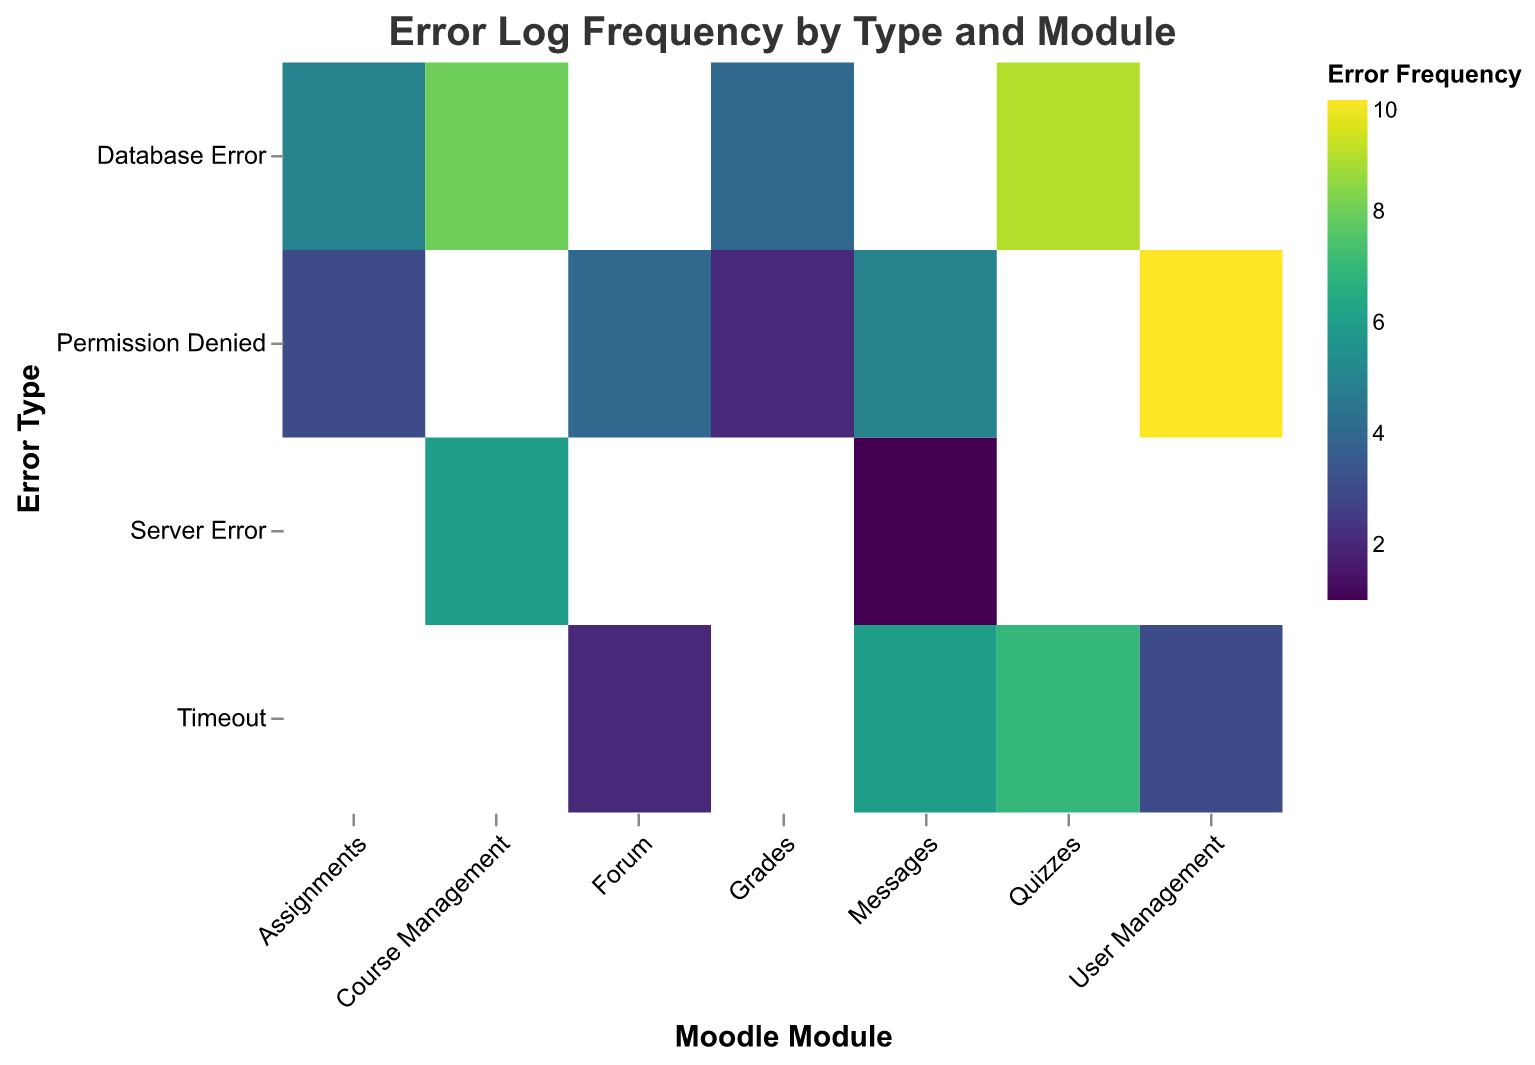What's the title of the figure? The title of the figure is usually located at the top of the chart and describes what the visualization is about. In this case, it is "Error Log Frequency by Type and Module".
Answer: Error Log Frequency by Type and Module How many different error types are there in the chart? The y-axis of the chart lists the distinct error types. By counting these labels, we can determine the number of different error types.
Answer: 5 Which module has the highest error frequency for 'Permission Denied'? Locate the 'Permission Denied' row on the y-axis, then identify which module column has the highest color intensity in that row based on the heatmap's color scale. The tooltip can also show this information.
Answer: User Management What is the total frequency of 'Database Error' across all modules? Sum the frequencies of 'Database Error' for each module by locating 'Database Error' in the y-axis and summing its corresponding values across the modules. The values are 5 (Assignments) + 9 (Quizzes) + 8 (Course Management) + 4 (Grades) = 26.
Answer: 26 Which module has the least frequent 'Server Error'? Find 'Server Error' on the y-axis, then identify the module with the lowest value on the frequency scale for this error type. According to the data, 'Messages' has the least value of 1.
Answer: Messages How many modules have a 'Timeout' frequency greater than 5? Locate the 'Timeout' row and count the modules where the frequency value is greater than 5 based on the color scale or the actual values. There are two such modules: Quizzes (7) and Messages (6).
Answer: 2 What is the most common error in the 'Forum' module? Locate the 'Forum' column and determine which error type has the highest frequency based on the color intensity or the tooltip values. 'Permission Denied' with a frequency of 4 is the highest.
Answer: Permission Denied Which error type is most frequent in the heatmap? Observe all the error types and sum their frequencies across all modules to determine which one has the highest total value. 'Permission Denied' has the highest total frequency when combining values from different modules: 3 (Assignments) + 4 (Forum) + 10 (User Management) + 2 (Grades) + 5 (Messages) = 24.
Answer: Permission Denied Are there any modules without 'Server Error'? Review the 'Server Error' row to see if there are any empty cells or cells with a value of zero for each module. All modules except 'Assignments', 'Quizzes', 'Forum', 'Grades', and 'User Management' do not have values indicated, implying no 'Server Error'.
Answer: Assignments, Quizzes, Forum, Grades, User Management Which module has the highest combined error frequency? To find the module with the highest combined frequency, sum up all the errors for each module: Assignments (5+3=8), Quizzes (7+9=16), Forum (2+4=6), Course Management (6+8=14), User Management (10+3=13), Grades (4+2=6), Messages (1+6+5=12). The module 'Quizzes' has the highest combined error frequency (16).
Answer: Quizzes 